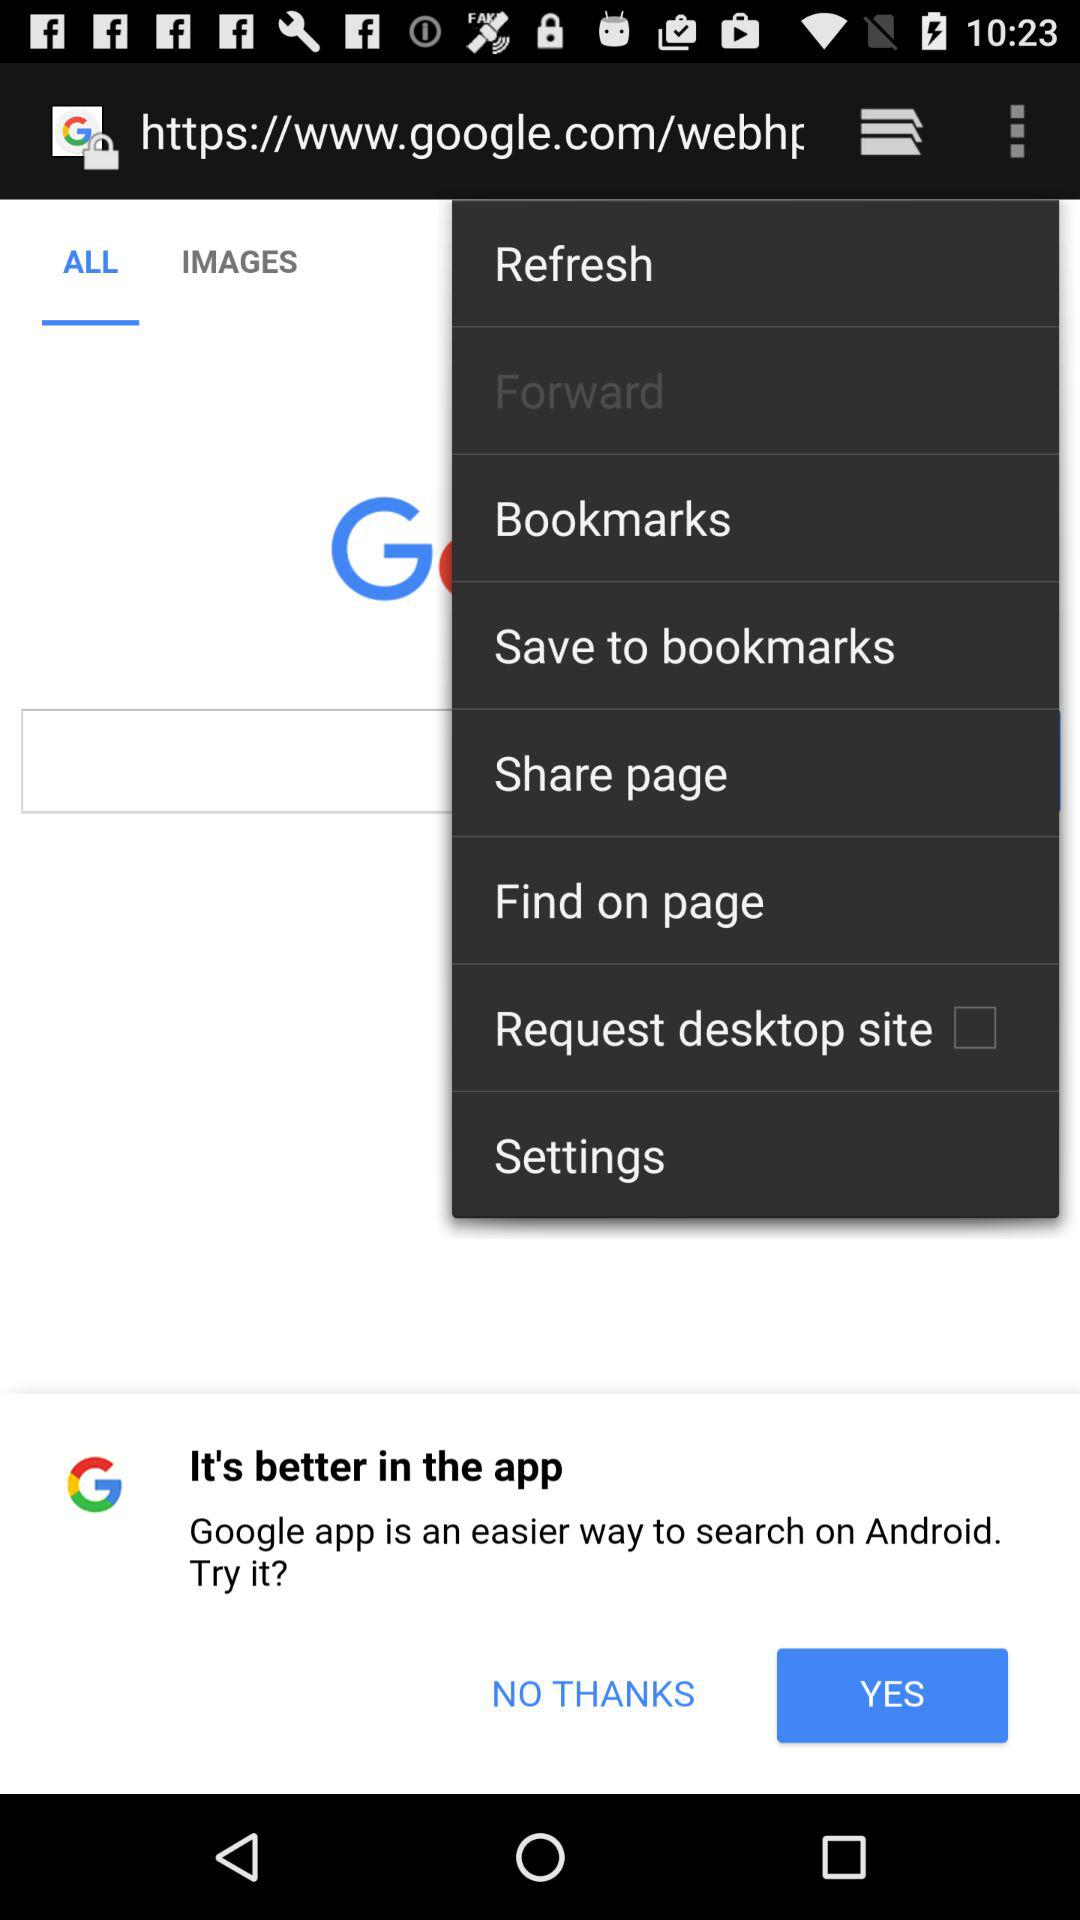Which item is selected in the menu? The selected item in the menu is "Forward". 